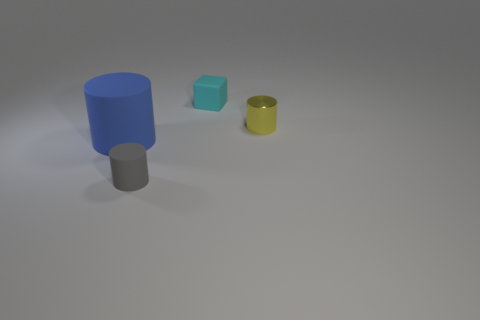What number of objects are either large green rubber cylinders or cylinders that are on the right side of the rubber cube?
Ensure brevity in your answer.  1. The cylinder that is both to the right of the blue matte cylinder and to the left of the cyan thing is made of what material?
Offer a very short reply. Rubber. Are there any other things that have the same shape as the large thing?
Provide a succinct answer. Yes. What is the color of the tiny block that is made of the same material as the gray cylinder?
Keep it short and to the point. Cyan. How many things are small cyan balls or cylinders?
Make the answer very short. 3. There is a blue cylinder; is it the same size as the gray rubber cylinder on the left side of the small yellow metallic cylinder?
Provide a short and direct response. No. There is a small cylinder in front of the tiny object that is on the right side of the small object that is behind the yellow thing; what is its color?
Provide a succinct answer. Gray. The large matte object has what color?
Provide a short and direct response. Blue. Is the number of tiny gray objects that are to the right of the big blue matte cylinder greater than the number of rubber cylinders in front of the gray matte cylinder?
Offer a terse response. Yes. Does the blue object have the same shape as the small object on the right side of the cube?
Offer a terse response. Yes. 